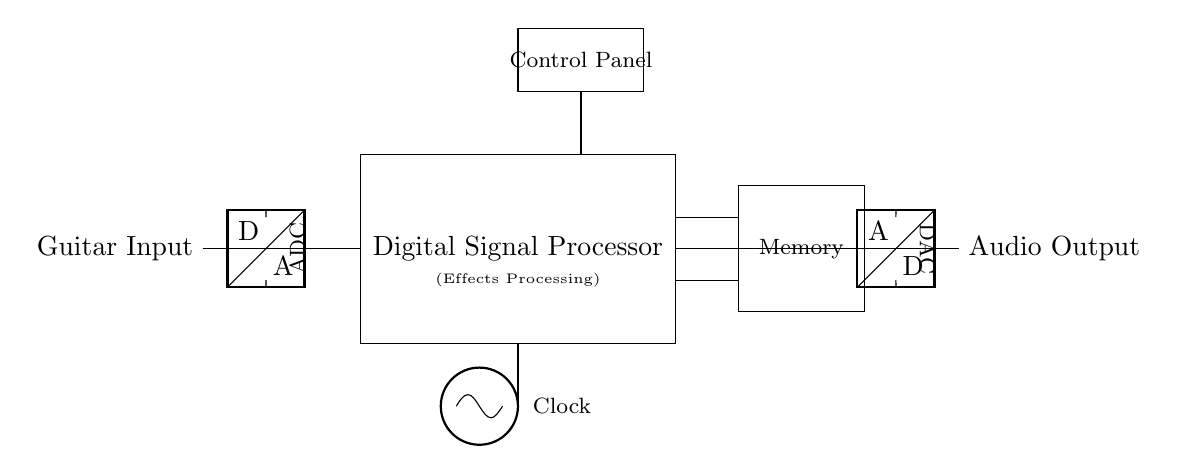What component is connected to the guitar input? The ADC is directly connected to the guitar input, as indicated by the line connecting the two. The ADC, or Analog to Digital Converter, is responsible for converting the analog signal from the guitar input into a digital signal for processing.
Answer: ADC What does the large rectangle represent in the diagram? The large rectangle in the diagram is labeled as "Digital Signal Processor," which signifies the main block where the audio effects processing occurs. Within this rectangle, various digital effects can be applied to the guitar signal after conversion by the ADC.
Answer: Digital Signal Processor What is the purpose of the clock in this circuit? The clock's role is to synchronize the operations of the components within the circuit, particularly the digital signal processor. It provides consistent timing signals that help in coordinating data processing tasks, ensuring the system runs efficiently.
Answer: Synchronization How many output connections are there in the circuit? There are two output connections in the circuit diagram, one for the DAC and another for the audio output; they are depicted by the lines leading from the DAC to other components. These connections allow the processed audio signal to exit the processor and be sent to speakers or amplifiers.
Answer: Two Which component is used for storing data in the circuit? The Memory component is indicated as a rectangle to the right of the DSP. This component is used for storing data, such as audio samples or effect parameters, which can be accessed by the DSP for real-time processing.
Answer: Memory What type of conversion occurs before the digital signal processing? The conversion that occurs before the digital signal processing is from analog to digital, performed by the ADC (Analog to Digital Converter). This step is crucial for capturing the analog audio signal from the guitar into a format suitable for digital processing.
Answer: Analog to Digital What does the control panel control in this circuit? The control panel is responsible for user input, allowing the guitarist to select different effects or adjust parameters on the digital signal processor. This interaction influences how the processed audio signal will sound.
Answer: User Input 